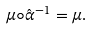Convert formula to latex. <formula><loc_0><loc_0><loc_500><loc_500>\mu \circ \hat { \alpha } ^ { - 1 } = \mu .</formula> 